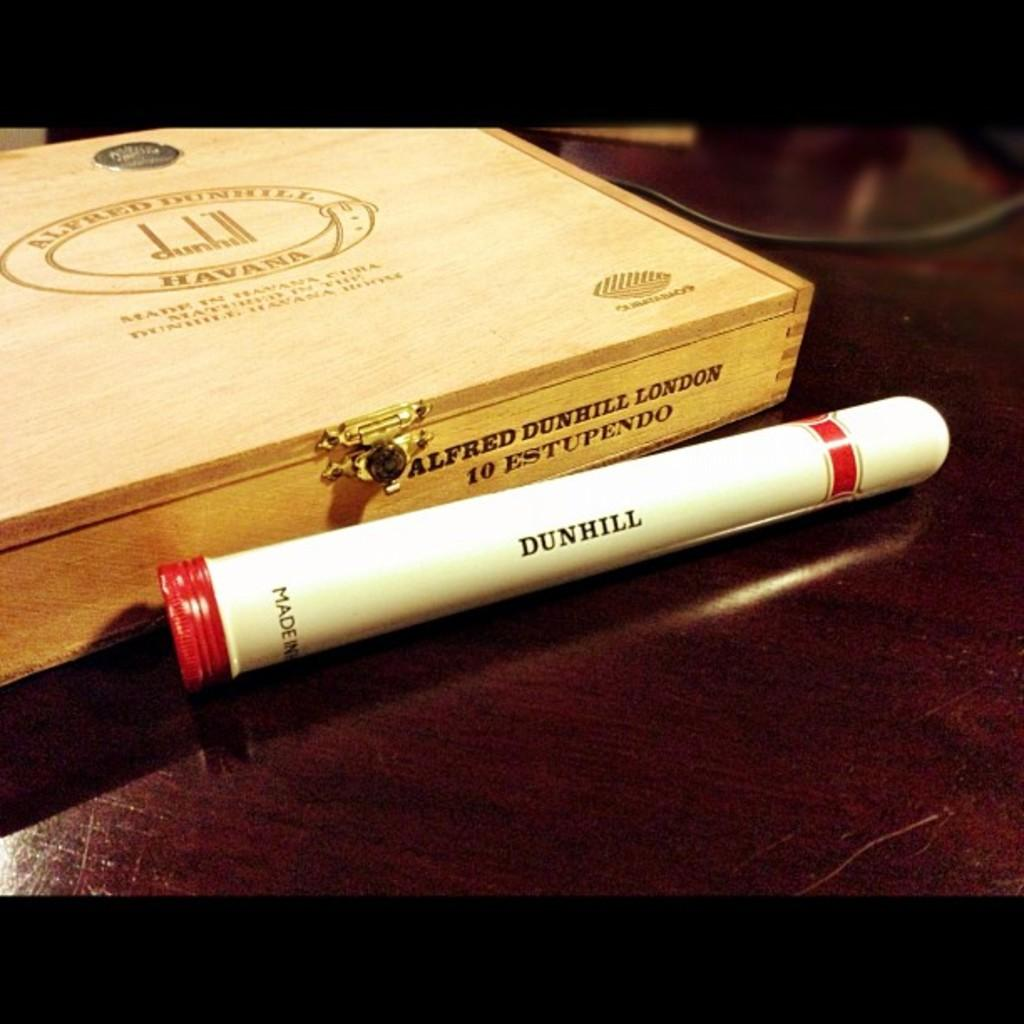<image>
Present a compact description of the photo's key features. A box of Dunhill cigars, and one Dunhill cigar outside the case. 